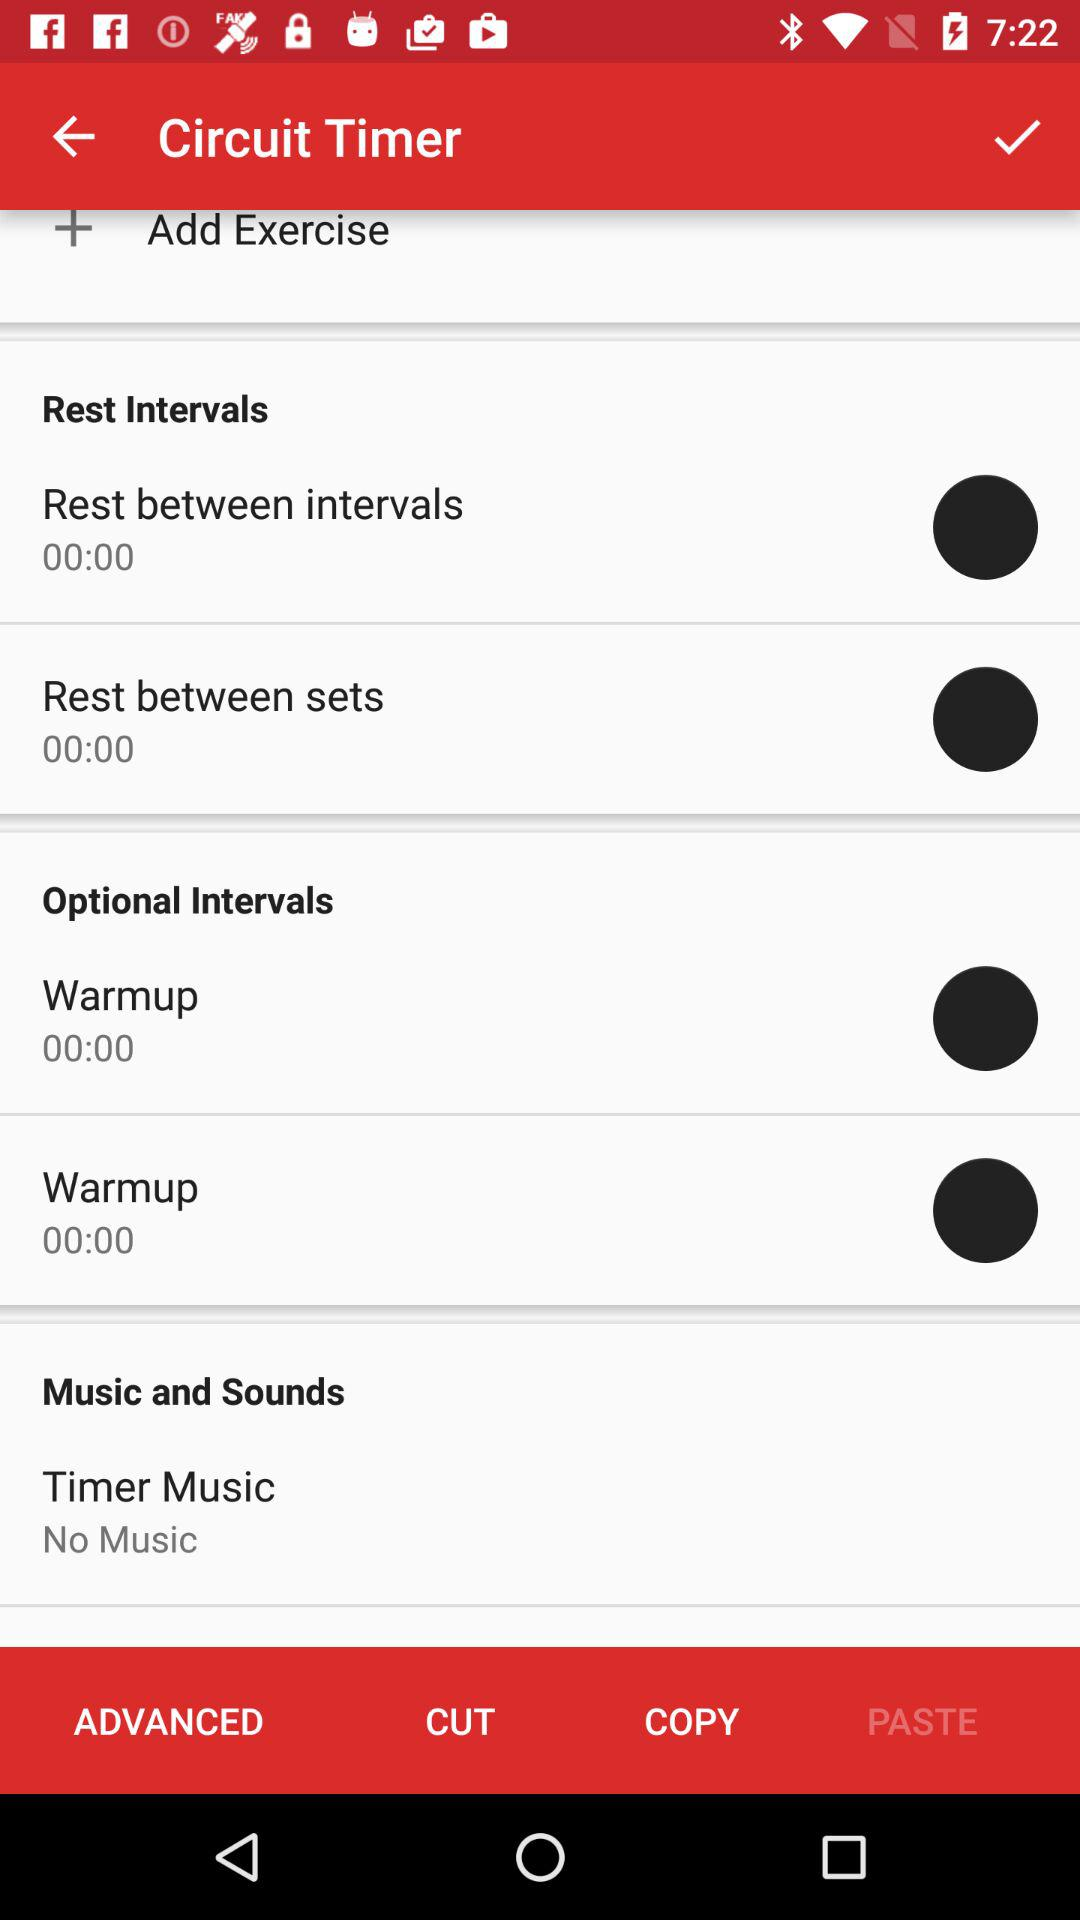What is the rest time between intervals? The rest time between intervals is 0. 